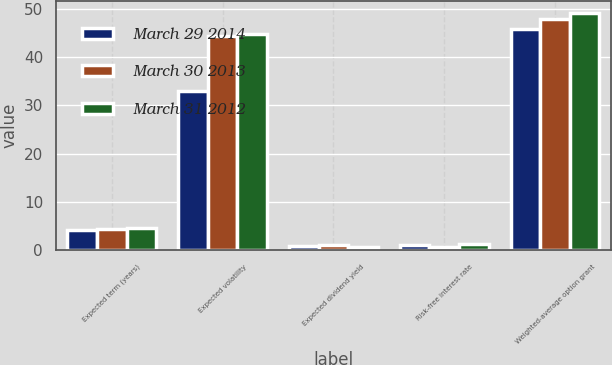Convert chart to OTSL. <chart><loc_0><loc_0><loc_500><loc_500><stacked_bar_chart><ecel><fcel>Expected term (years)<fcel>Expected volatility<fcel>Expected dividend yield<fcel>Risk-free interest rate<fcel>Weighted-average option grant<nl><fcel>March 29 2014<fcel>4.2<fcel>32.9<fcel>0.98<fcel>1.1<fcel>45.83<nl><fcel>March 30 2013<fcel>4.5<fcel>44.3<fcel>1.05<fcel>0.6<fcel>47.89<nl><fcel>March 31 2012<fcel>4.7<fcel>44.7<fcel>0.72<fcel>1.3<fcel>49.13<nl></chart> 